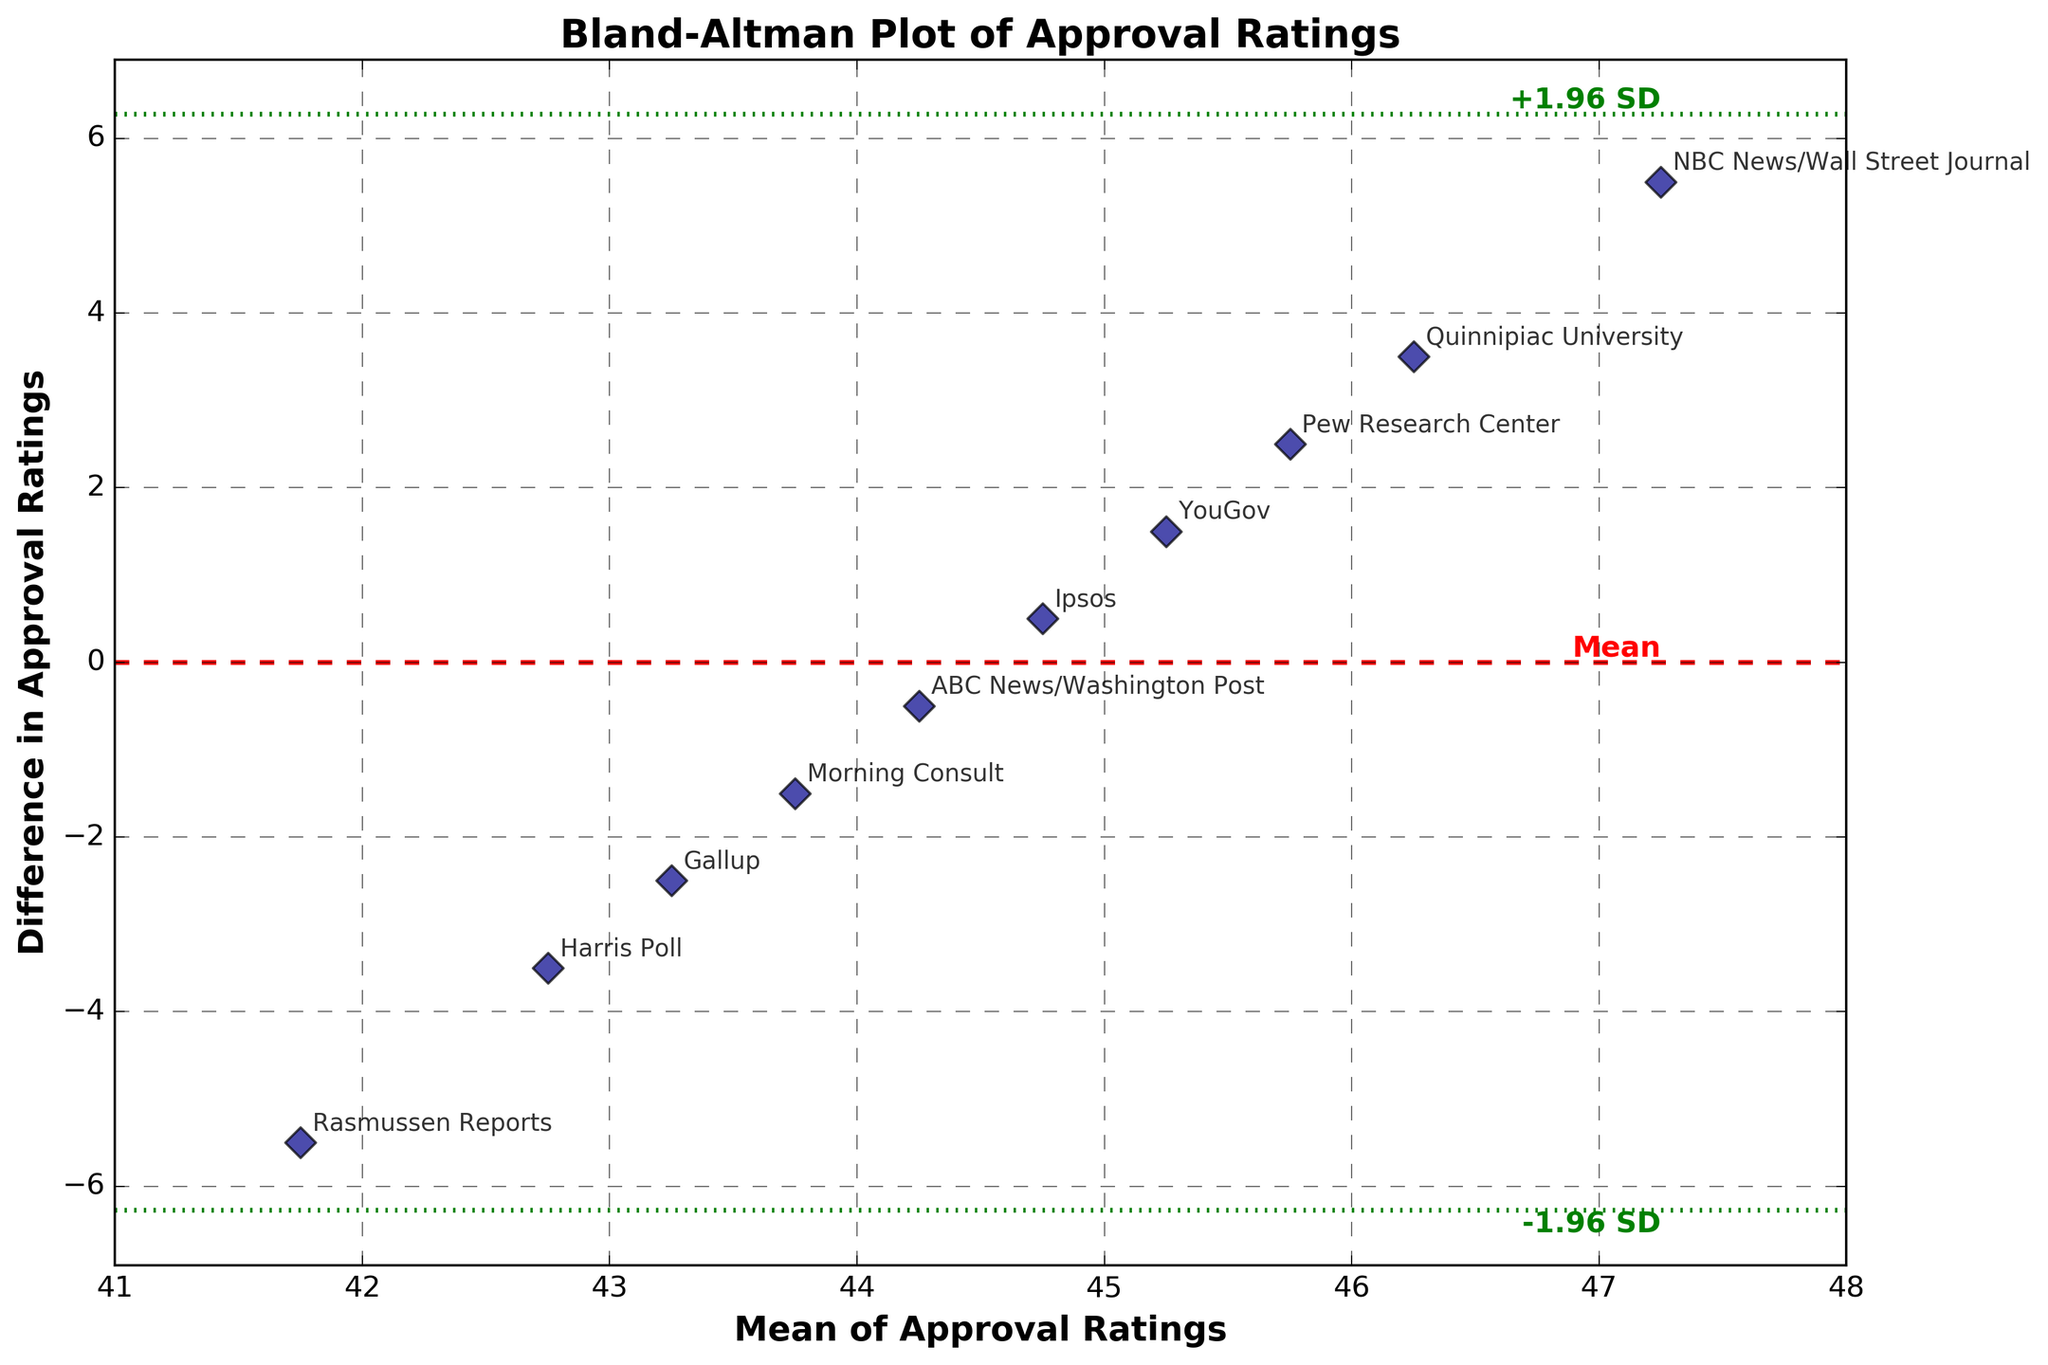What is the title of the plot? The title is located at the top of the figure and indicates the subject of the plot.
Answer: Bland-Altman Plot of Approval Ratings What does the x-axis represent in this plot? The x-axis represents the mean of approval ratings from different polling organizations. This is calculated as the average of each polling organization's approval rating and the overall average rating.
Answer: Mean of Approval Ratings How many polling organizations are represented in the plot? Each data point corresponds to a polling organization, and each point is labeled with the organization name. By counting these points, we determine the number of polling organizations.
Answer: 10 Which polling organization shows the largest positive difference from the average rating? By identifying the data point with the highest value on the y-axis (difference), we can determine which polling organization has the largest positive difference.
Answer: NBC News/Wall Street Journal What is the mean difference between approval ratings and the average rating? The mean difference is the horizontal red dashed line in the plot. It indicates the average difference between each polling organization's rating and the overall average rating.
Answer: 0.0 What are the limits of agreement in the plot? The limits of agreement are indicated by the green dotted lines, above and below the mean difference line. They show the range within which most differences between the approval ratings and the average rating will fall.
Answer: -5.17 to 5.17 Which two polling organizations have approval ratings closest to the average rating? By finding the data points closest to the zero line on the y-axis (difference) and checking their labels, we identify the polling organizations with approval ratings closest to the average.
Answer: ABC News/Washington Post and Morning Consult How much higher is the approval rating from Quinnipiac University compared to the average rating? The difference for Quinnipiac University is shown by its data point on the y-axis. By reading this value, we can determine how much higher Quinnipiac University's approval rating is compared to the average.
Answer: 3.5 What does a data point above the red dashed line indicate? A data point above the red dashed line indicates a polling organization whose approval rating is higher than the average rating.
Answer: Higher rating Between Gallup and YouGov, which organization’s approval rating is closer to the average? By comparing the y-values (differences) of the data points corresponding to Gallup and YouGov, we see which one is closer to zero, indicating a rating closer to the average.
Answer: Gallup 